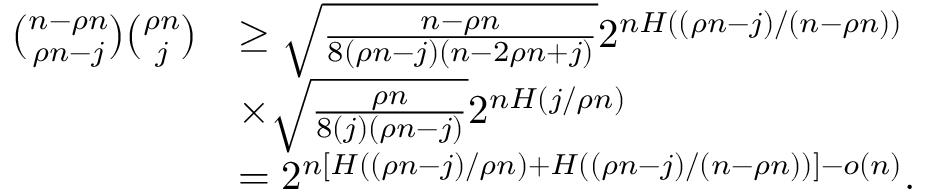Convert formula to latex. <formula><loc_0><loc_0><loc_500><loc_500>\begin{array} { r l } { { \binom { n - \rho n } { \rho n - j } } { \binom { \rho n } { j } } } & { \geq \sqrt { \frac { n - \rho n } { 8 ( \rho n - j ) ( n - 2 \rho n + j ) } } 2 ^ { n { H ( ( \rho n - j ) / ( n - \rho n ) ) } } } \\ & { \times \sqrt { \frac { \rho n } { 8 ( j ) ( \rho n - j ) } } 2 ^ { n { H ( j / \rho n ) } } } \\ & { = 2 ^ { n [ H ( ( \rho n - j ) / \rho n ) + H ( ( \rho n - j ) / ( n - \rho n ) ) ] - o ( n ) } . } \end{array}</formula> 